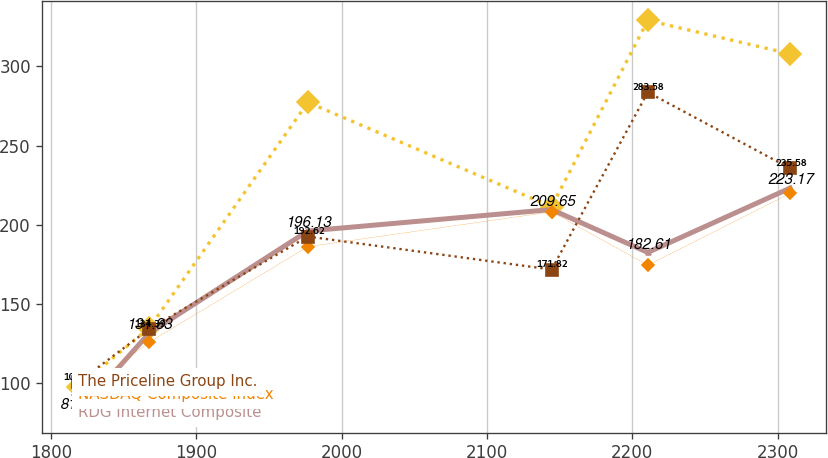Convert chart to OTSL. <chart><loc_0><loc_0><loc_500><loc_500><line_chart><ecel><fcel>S&P 500 Index<fcel>RDG Internet Composite<fcel>NASDAQ Composite Index<fcel>The Priceline Group Inc.<nl><fcel>1818.77<fcel>97.92<fcel>81.42<fcel>92.77<fcel>100.77<nl><fcel>1867.75<fcel>135<fcel>131.83<fcel>126.07<fcel>134.39<nl><fcel>1976.86<fcel>277.2<fcel>196.13<fcel>186.24<fcel>192.62<nl><fcel>2144.47<fcel>211.4<fcel>209.65<fcel>208.17<fcel>171.82<nl><fcel>2210.62<fcel>328.85<fcel>182.61<fcel>174.58<fcel>283.58<nl><fcel>2308.55<fcel>307.76<fcel>223.17<fcel>219.83<fcel>235.58<nl></chart> 